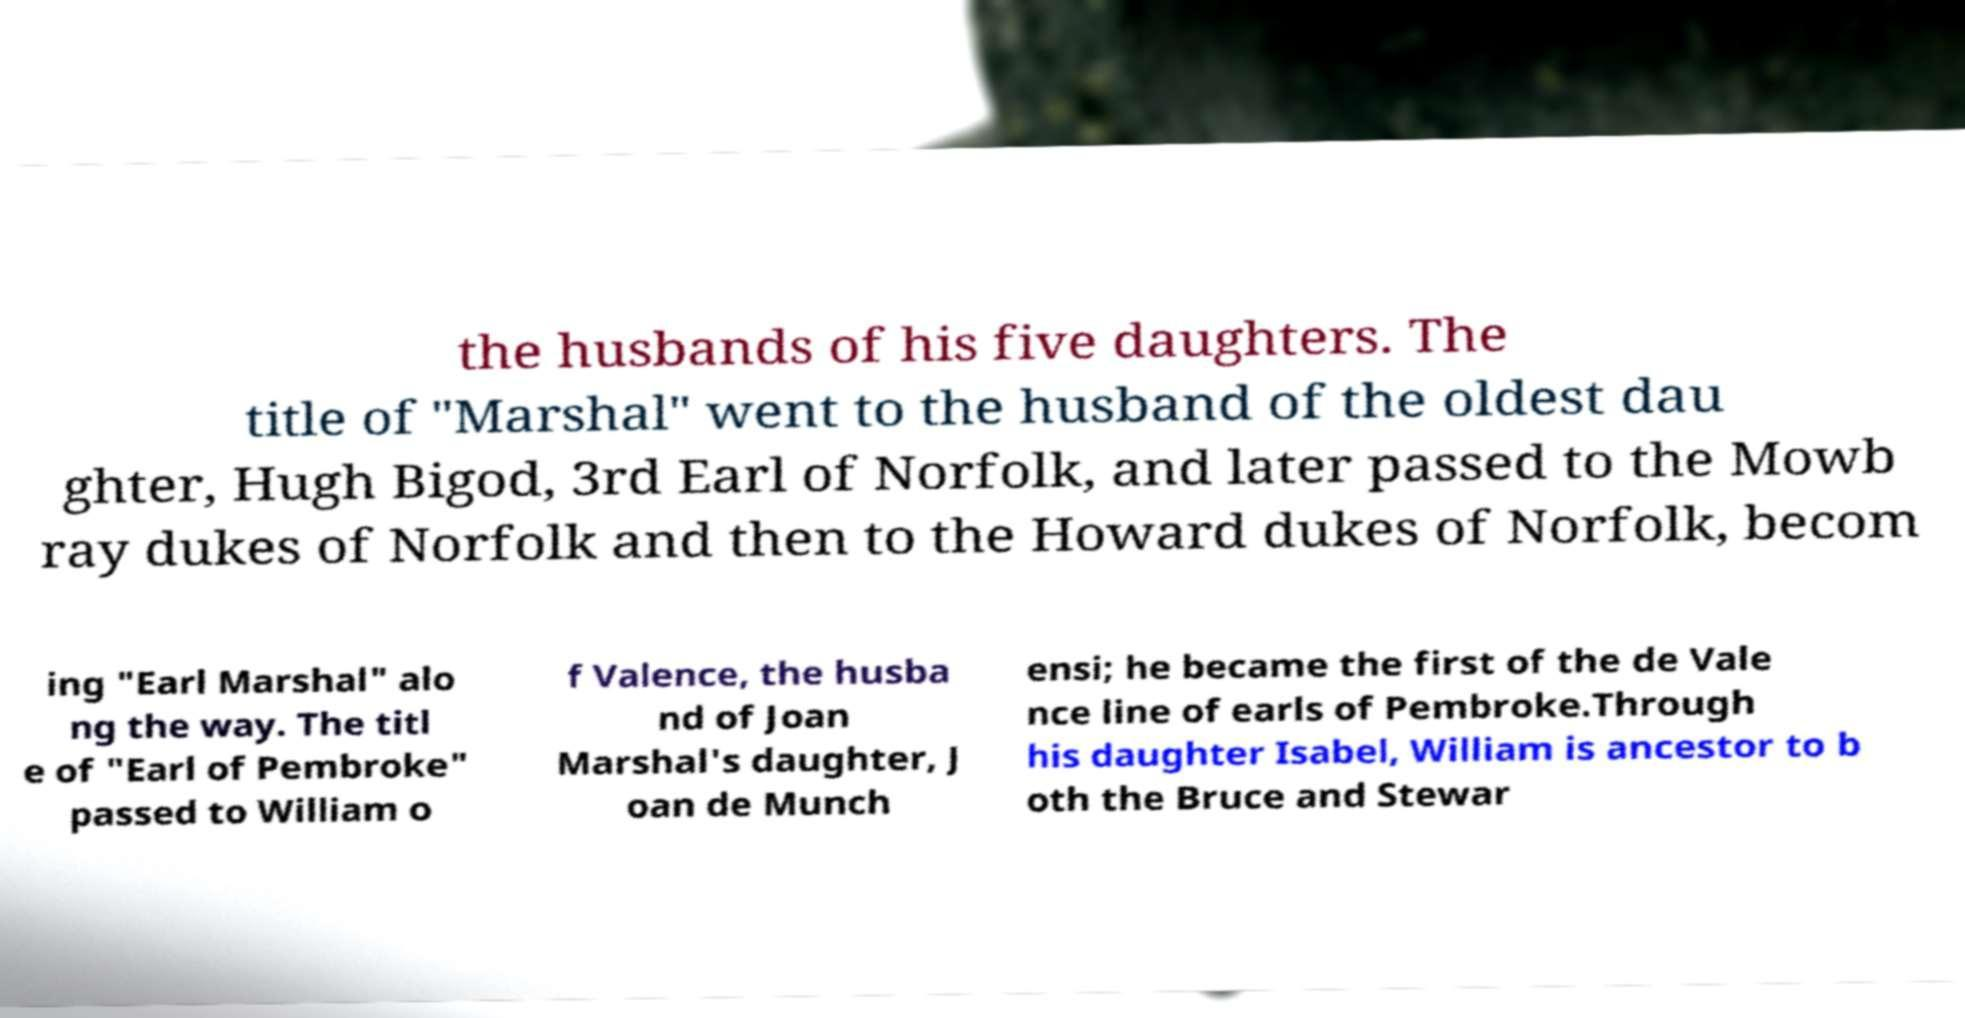For documentation purposes, I need the text within this image transcribed. Could you provide that? the husbands of his five daughters. The title of "Marshal" went to the husband of the oldest dau ghter, Hugh Bigod, 3rd Earl of Norfolk, and later passed to the Mowb ray dukes of Norfolk and then to the Howard dukes of Norfolk, becom ing "Earl Marshal" alo ng the way. The titl e of "Earl of Pembroke" passed to William o f Valence, the husba nd of Joan Marshal's daughter, J oan de Munch ensi; he became the first of the de Vale nce line of earls of Pembroke.Through his daughter Isabel, William is ancestor to b oth the Bruce and Stewar 